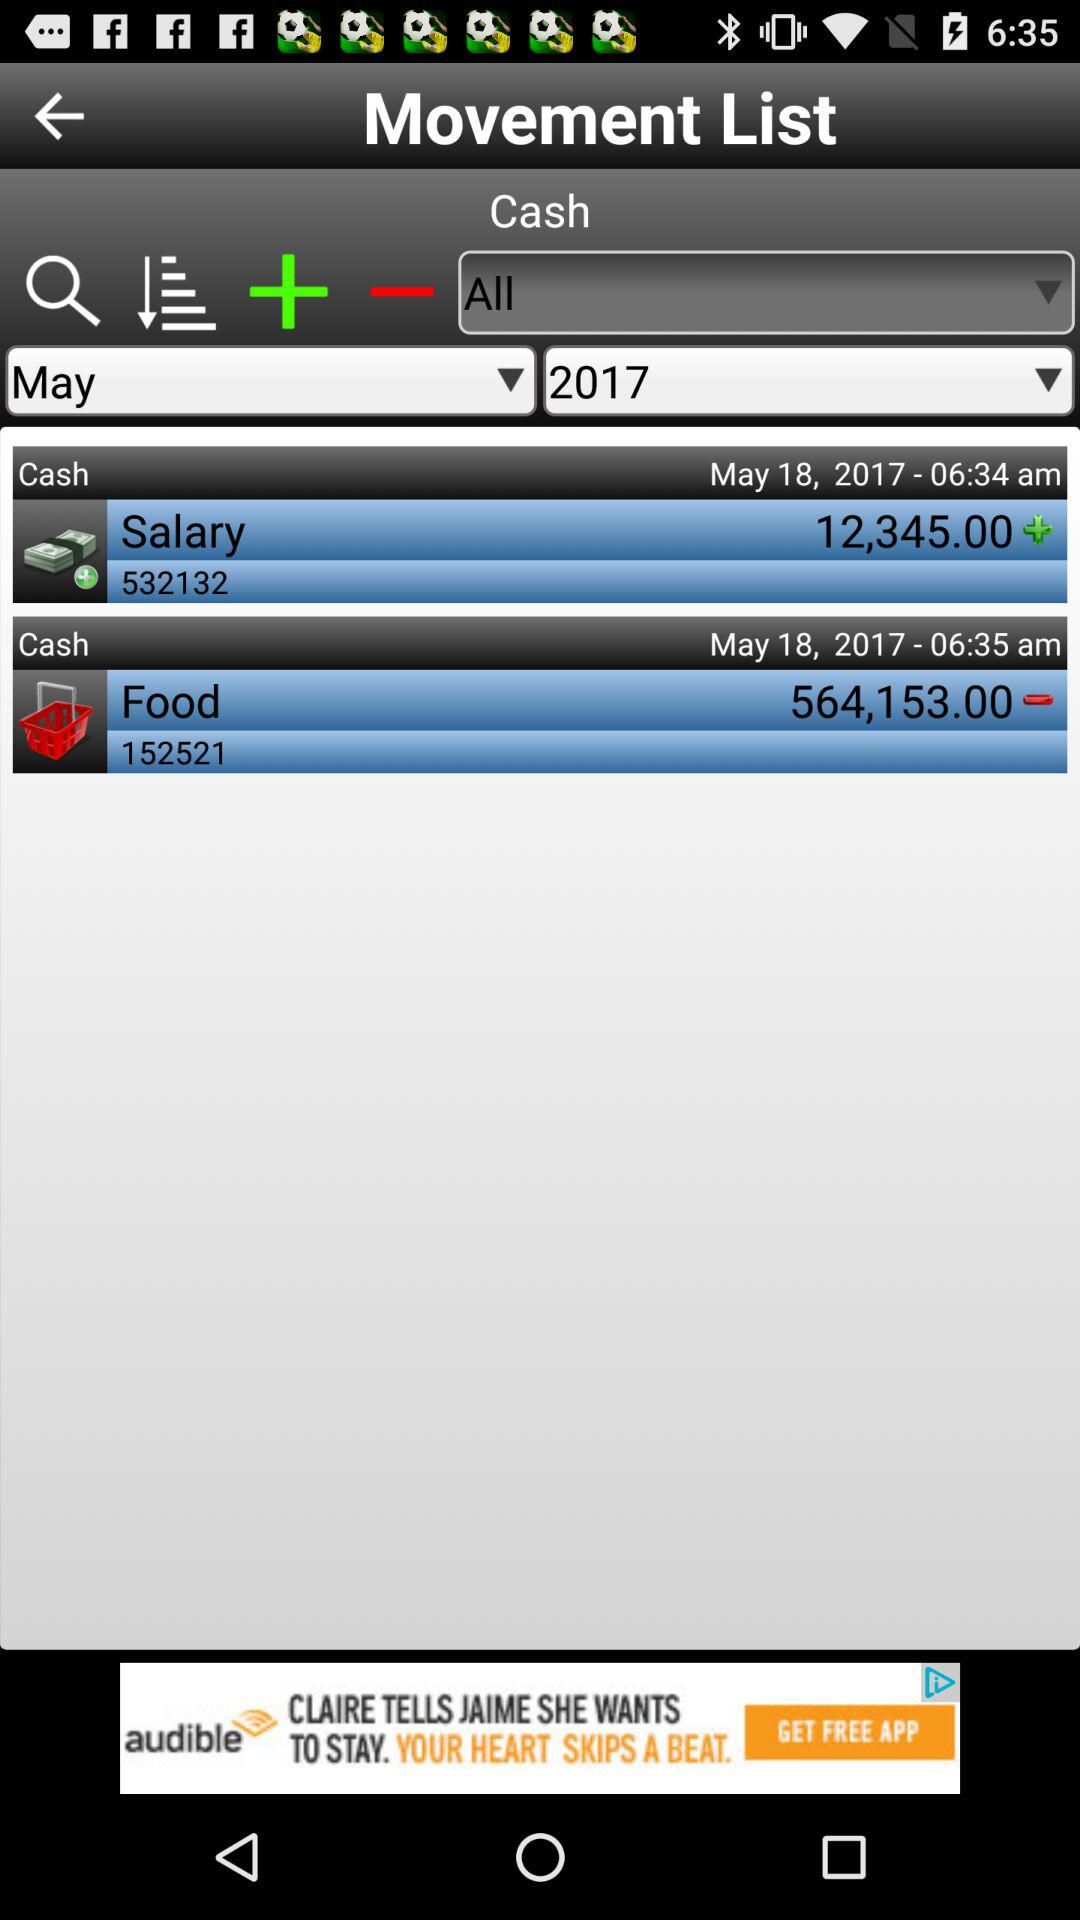How much has been paid for food expenses? The paid expense for food is 564,153. 